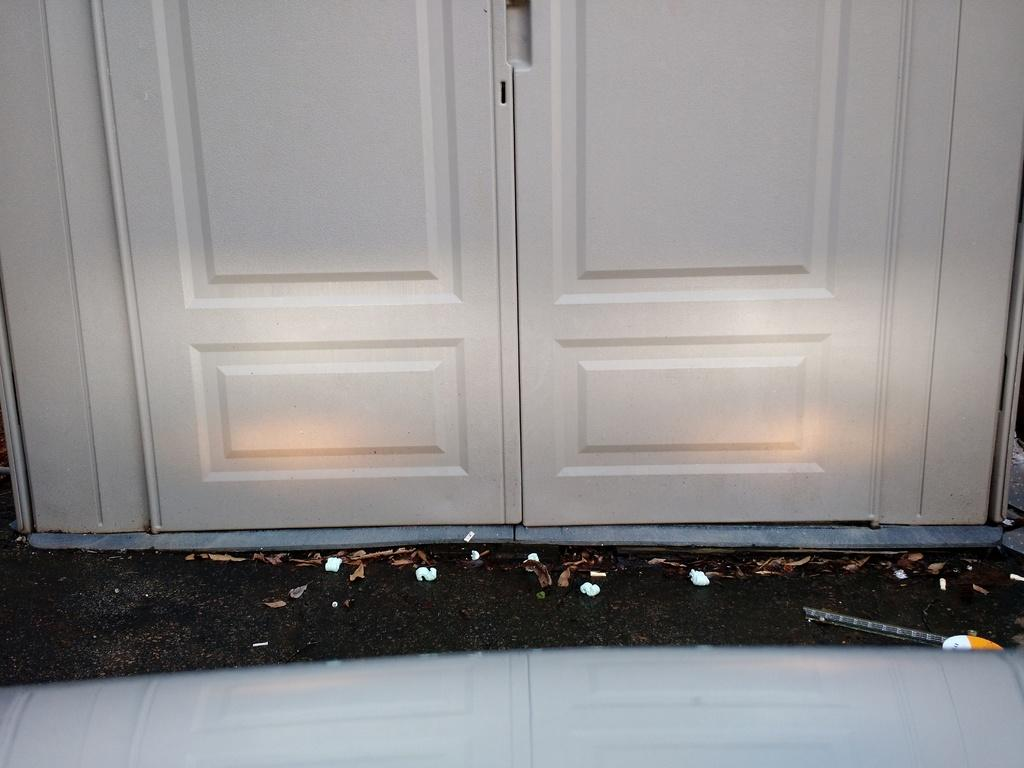What is the main object in the image? There is a door in the image. What can be seen on the floor near the door? There are shredded leaves on the floor in the image. What color is the kitten's tail in the image? There is no kitten or tail present in the image. Is the train visible through the door in the image? There is no train visible in the image, and the door does not show a view of the outside. 